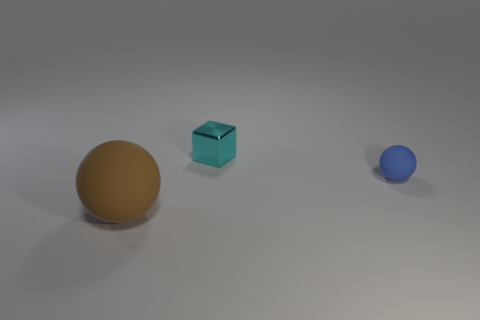Add 2 brown balls. How many objects exist? 5 Subtract all brown balls. How many balls are left? 1 Subtract 1 balls. How many balls are left? 1 Subtract all blocks. How many objects are left? 2 Subtract all gray spheres. Subtract all gray cylinders. How many spheres are left? 2 Subtract all yellow cylinders. How many brown balls are left? 1 Subtract all small blue rubber things. Subtract all big brown rubber spheres. How many objects are left? 1 Add 1 cyan objects. How many cyan objects are left? 2 Add 2 big brown spheres. How many big brown spheres exist? 3 Subtract 0 green cylinders. How many objects are left? 3 